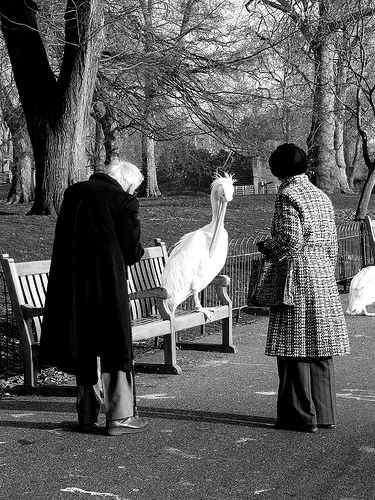Please provide a short description for this region: [0.13, 0.47, 0.6, 0.77]. A wooden bench with three armrests, placed in a park setting. 